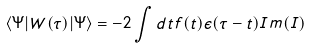<formula> <loc_0><loc_0><loc_500><loc_500>\left < \Psi | W ( \tau ) | \Psi \right > = - 2 \int d t f ( t ) \epsilon ( \tau - t ) I m ( I )</formula> 